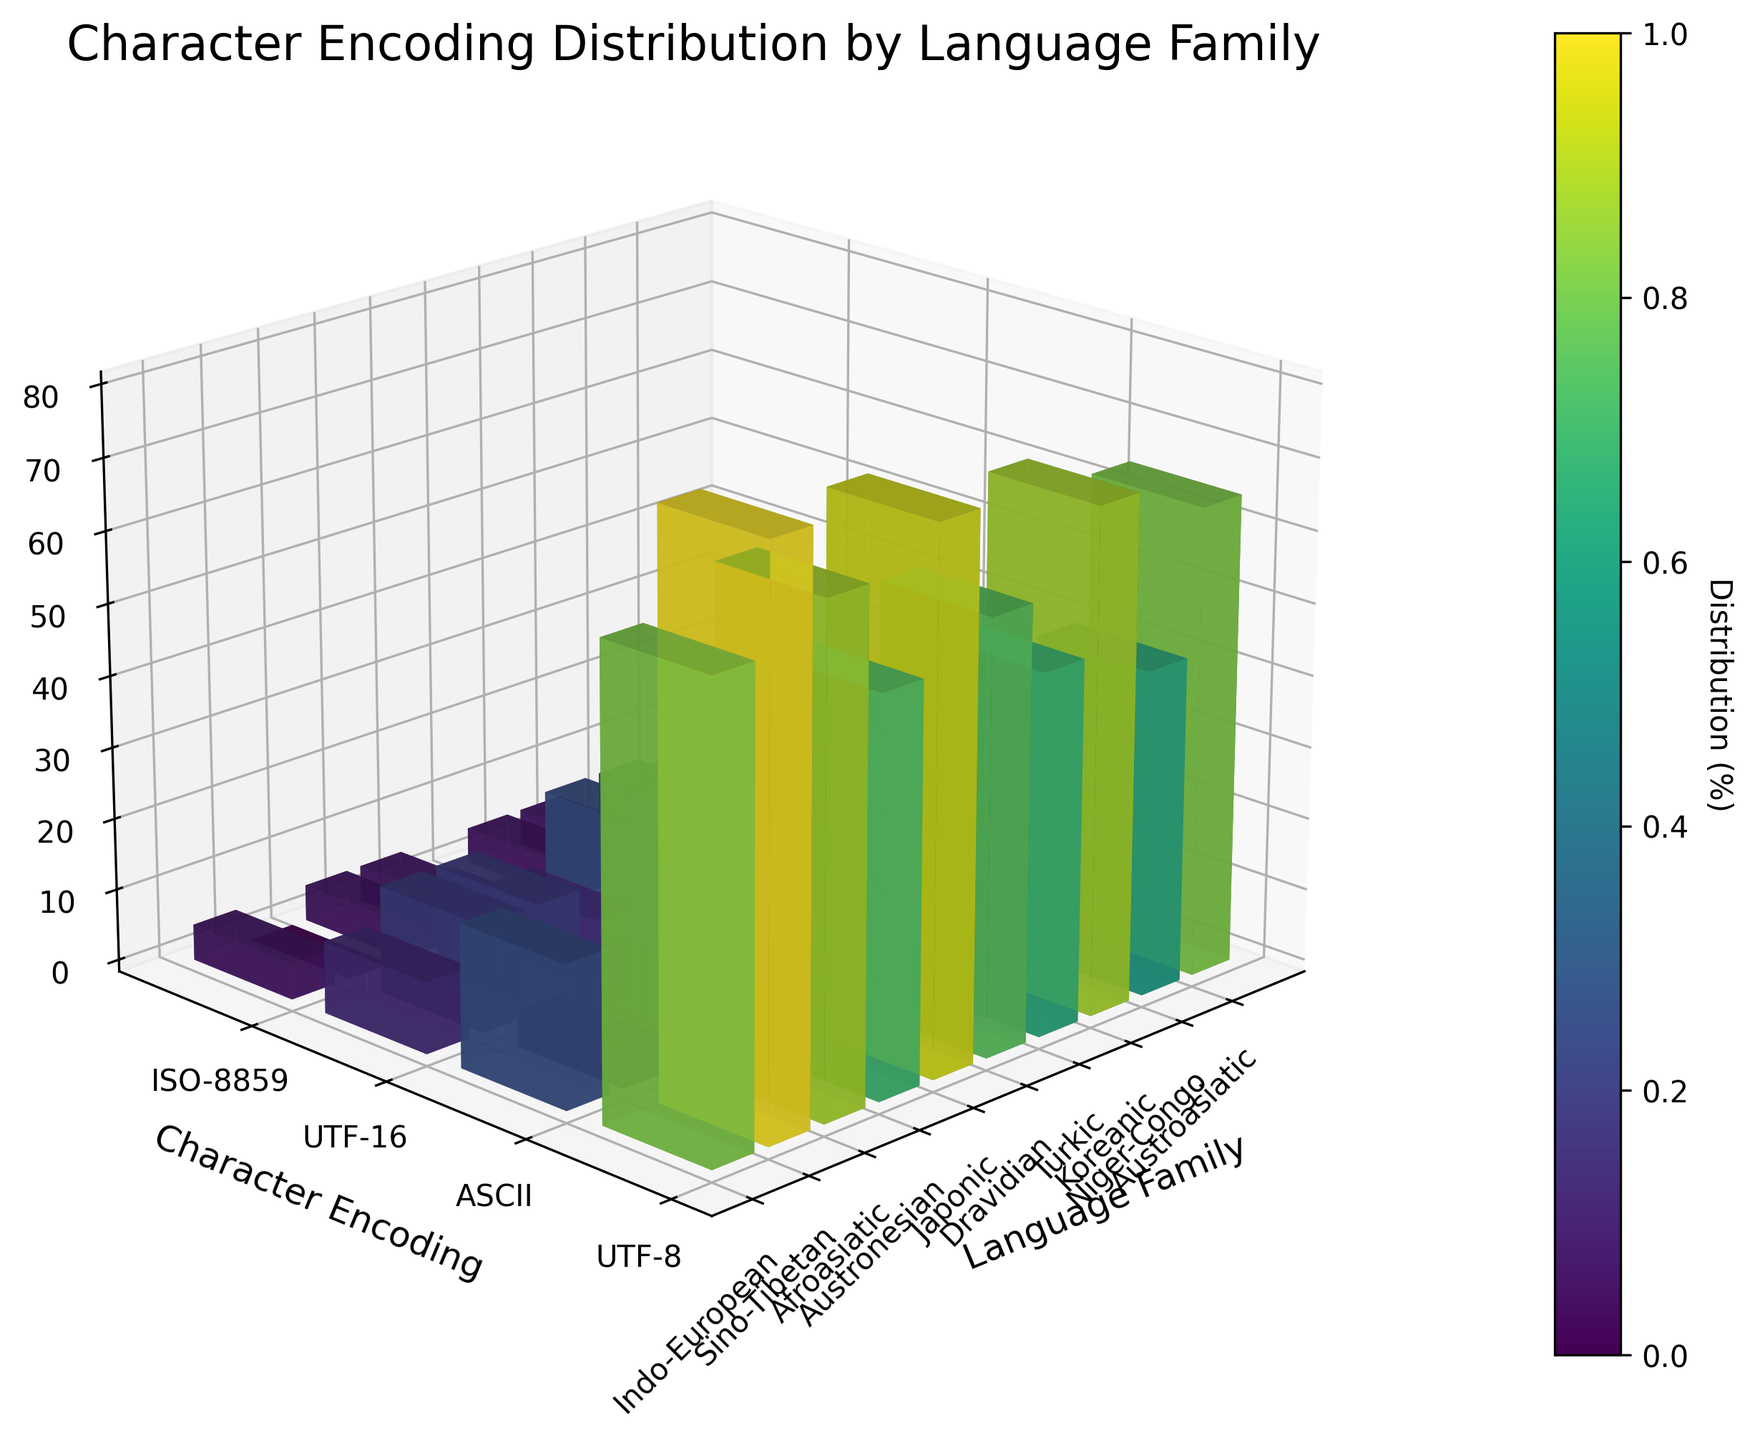How many encoding types are displayed in the plot? The plot has a y-axis labeled "Character Encoding," which lists the different encoding types. By counting the ticks on the y-axis, we can determine there are four encoding types: UTF-8, ASCII, UTF-16, and ISO-8859.
Answer: Four Which language family has the highest distribution of UTF-8 encoding? By looking at the height of the bars corresponding to UTF-8 encoding, we can see that the Sino-Tibetan family has the highest bar.
Answer: Sino-Tibetan What is the sum of the distributions of UTF-8 and ASCII encodings in the Indo-European family? By locating the Indo-European family's bars for UTF-8 and ASCII encodings on the plot, we sum the heights of both bars: 65 (UTF-8) + 20 (ASCII) = 85.
Answer: 85 Which writing system has the least distribution of ISO-8859 encoding? Observing the heights of the bars for ISO-8859 encoding across the different writing systems, we see that the Chinese and Japanese systems have the smallest values, both with a height of 0.
Answer: Chinese and Japanese Compare the distribution of UTF-16 encoding in the Japonic and Koreanic language families. Which one is higher? By comparing the heights of the UTF-16 bars for Japonic (20) and Koreanic (20), we see that they are equal.
Answer: Equal What is the difference in the distribution of UTF-8 encoding between the Afroasiatic and Turkic families? Observing the heights of the UTF-8 bars for Afroasiatic (70) and Turkic (50) families, the difference is 70 - 50 = 20.
Answer: 20 Which encoding type has the largest variance in distribution among all language families? By estimating the variation in bar heights for each encoding type across different language families, UTF-8 appears to have the largest range from smallest to largest values.
Answer: UTF-8 Is there any language family that uses only UTF-8 without any usage of other encodings? Observing all the bars, we find no language family relies exclusively on UTF-8 without using at least some amount of other encodings.
Answer: No Which language family has the most balanced distribution across all four encoding types? By looking at the bars representing each encoding type for each language family, the Turkic family appears the most balanced, with bars of similar heights for each encoding type.
Answer: Turkic 